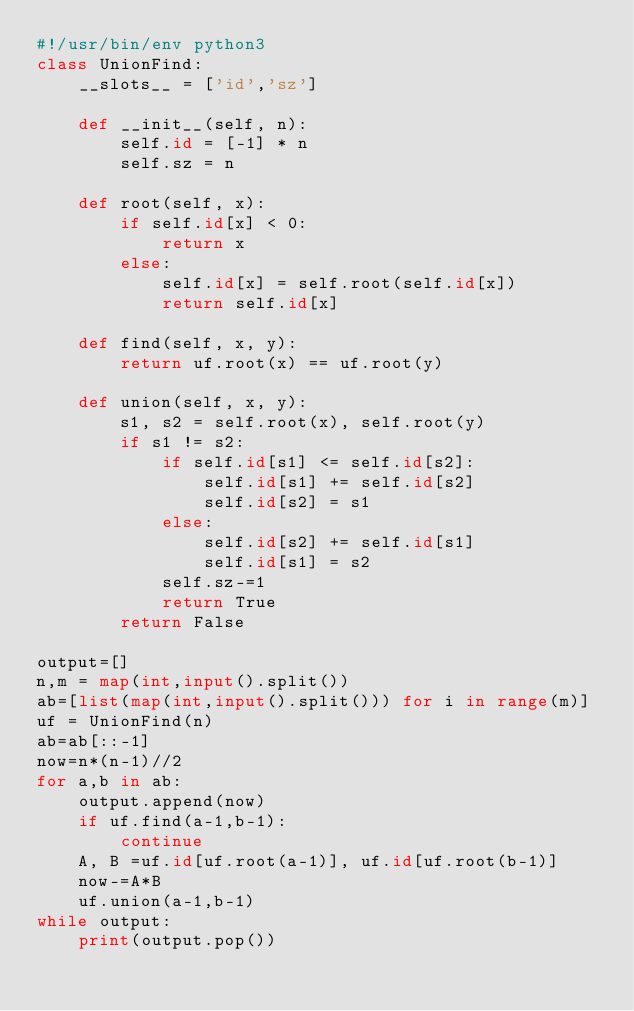Convert code to text. <code><loc_0><loc_0><loc_500><loc_500><_Python_>#!/usr/bin/env python3
class UnionFind:
    __slots__ = ['id','sz']

    def __init__(self, n):
        self.id = [-1] * n
        self.sz = n

    def root(self, x):
        if self.id[x] < 0:
            return x
        else:
            self.id[x] = self.root(self.id[x])
            return self.id[x]

    def find(self, x, y):
        return uf.root(x) == uf.root(y)

    def union(self, x, y):
        s1, s2 = self.root(x), self.root(y)
        if s1 != s2:
            if self.id[s1] <= self.id[s2]:
                self.id[s1] += self.id[s2]
                self.id[s2] = s1
            else:
                self.id[s2] += self.id[s1]
                self.id[s1] = s2
            self.sz-=1
            return True
        return False

output=[]
n,m = map(int,input().split())
ab=[list(map(int,input().split())) for i in range(m)]
uf = UnionFind(n)
ab=ab[::-1]
now=n*(n-1)//2
for a,b in ab:
    output.append(now)
    if uf.find(a-1,b-1):
        continue
    A, B =uf.id[uf.root(a-1)], uf.id[uf.root(b-1)]
    now-=A*B
    uf.union(a-1,b-1)
while output:
    print(output.pop())



    </code> 